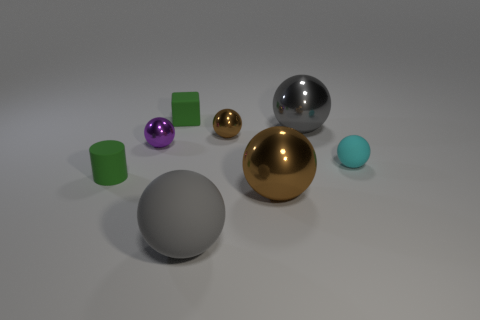Is the number of balls on the right side of the purple metallic object greater than the number of small brown things that are in front of the tiny brown ball?
Offer a very short reply. Yes. Does the tiny rubber thing on the left side of the matte block have the same color as the small block that is left of the small cyan thing?
Give a very brief answer. Yes. What size is the gray object to the right of the gray sphere in front of the gray ball on the right side of the large brown object?
Your response must be concise. Large. What is the color of the other tiny matte thing that is the same shape as the gray rubber thing?
Your response must be concise. Cyan. Is the number of green objects in front of the small purple shiny object greater than the number of small purple rubber objects?
Ensure brevity in your answer.  Yes. Do the big brown shiny thing and the rubber thing left of the tiny green block have the same shape?
Give a very brief answer. No. What size is the cyan thing that is the same shape as the purple object?
Your response must be concise. Small. Is the number of tiny brown things greater than the number of gray metallic cylinders?
Keep it short and to the point. Yes. There is a small sphere that is on the right side of the gray sphere that is behind the gray rubber thing; what is it made of?
Provide a short and direct response. Rubber. What is the material of the tiny thing that is the same color as the cube?
Provide a short and direct response. Rubber. 